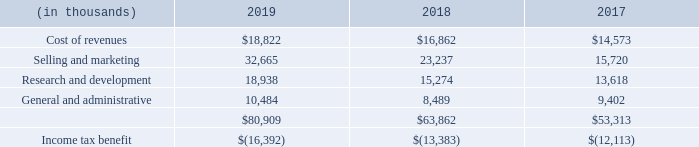14. STOCK-BASED COMPENSATION
The following table presents the stock-based compensation expense included in the Company’s consolidated statements of operations:
The Company periodically grants stock options and restricted stock units (“RSUs”) for a fixed number of shares upon vesting to employees and non-employee Directors. Beginning in 2019, the Company granted Directors awards in the form of common stock and stock options
Most of the Company’s stock-based compensation arrangements vest over five years with 20% vesting after one year and the remaining 80% vesting in equal quarterly installments over the remaining four years. The Company’s stock options have a term of ten years. The Company recognizes stock-based compensation using the accelerated attribution method, treating each vesting tranche as if it were an individual grant. The amount of stock-based compensation recognized during a period is based on the value of the awards that are ultimately expected to vest. Forfeitures are estimated at the time of grant and revised, if necessary, in subsequent periods if actual forfeitures differ from those estimates. Ultimately, the Company recognizes the actual expense over the vesting period only for the shares that vest
Employees may elect to receive 50% of their target incentive compensation under the Company’s Corporate Incentive Compensation Plan (the “CICP”) in the form of RSUs instead of cash. If elected by an employee, the equity amount is equal in value on the date of grant to 50% of his or her target incentive opportunity, based on the employee’s base salary. The number of RSUs granted is determined by dividing 50% of the employee’s target incentive opportunity by 85% of the closing price of its common stock on the grant date, less the present value of expected dividends during the vesting period. If elected, the award vests 100% on the CICP payout date of the following year for all participants. Vesting is conditioned upon the performance conditions of the CICP and on continued employment; if threshold funding does not occur, the RSUs will not vest. The Company considers vesting to be probable on the grant date and recognizes the associated stockbased compensation expense over the requisite service period beginning on the grant date and ending on the vesting date.
The Company grants awards that allow for the settlement of vested stock options and RSUs on a net share basis (“net settled awards”). With net settled awards, the employee does not surrender any cash or shares upon exercise. Rather, the Company withholds the number of shares to cover the exercise price (in the case of stock options) and the minimum statutory tax withholding obligations (in the case of stock options and RSUs) from the shares that would otherwise be issued upon exercise or settlement. The exercise of stock options and settlement of RSUs on a net share basis results in fewer shares issued by the Company.
What are the company's respective stock-based compensation for  cost of revenues in 2019 and 2018?
Answer scale should be: thousand. $18,822, $16,862. What are the company's respective stock-based compensation for selling and marketing in 2019 and 2018?
Answer scale should be: thousand. 32,665, 23,237. What are the company's respective stock-based compensation for research and development in 2019 and 2018?
Answer scale should be: thousand. 18,938, 15,274. What is the company's average stock-based compensation for the cost of revenue between 2017 to 2019?
Answer scale should be: thousand. ($14,573 + $16,862 + $18,822)/3 
Answer: 16752.33. What is the company's average stock-based compensation for selling and marketing in 2018 and 2019?
Answer scale should be: thousand. (23,237 + 32,665)/2 
Answer: 27951. What is the company's average stock-based compensation for research and development in 2018 and 2019?
Answer scale should be: thousand. (18,938 + 15,274)/2
Answer: 17106. 